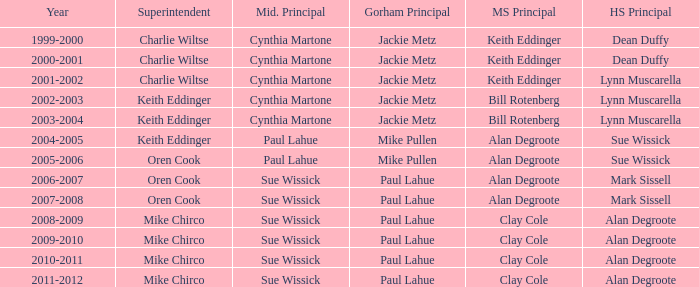Who were the superintendent(s) when the middle school principal was alan degroote, the gorham principal was paul lahue, and the year was 2006-2007? Oren Cook. 